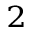<formula> <loc_0><loc_0><loc_500><loc_500>^ { 2 }</formula> 